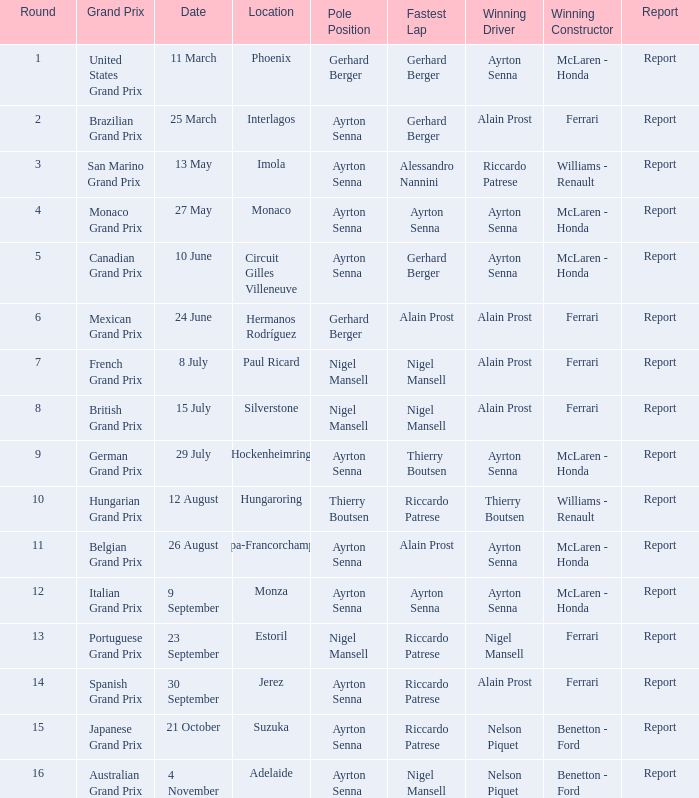What is the prime location for the german grand prix? Ayrton Senna. 